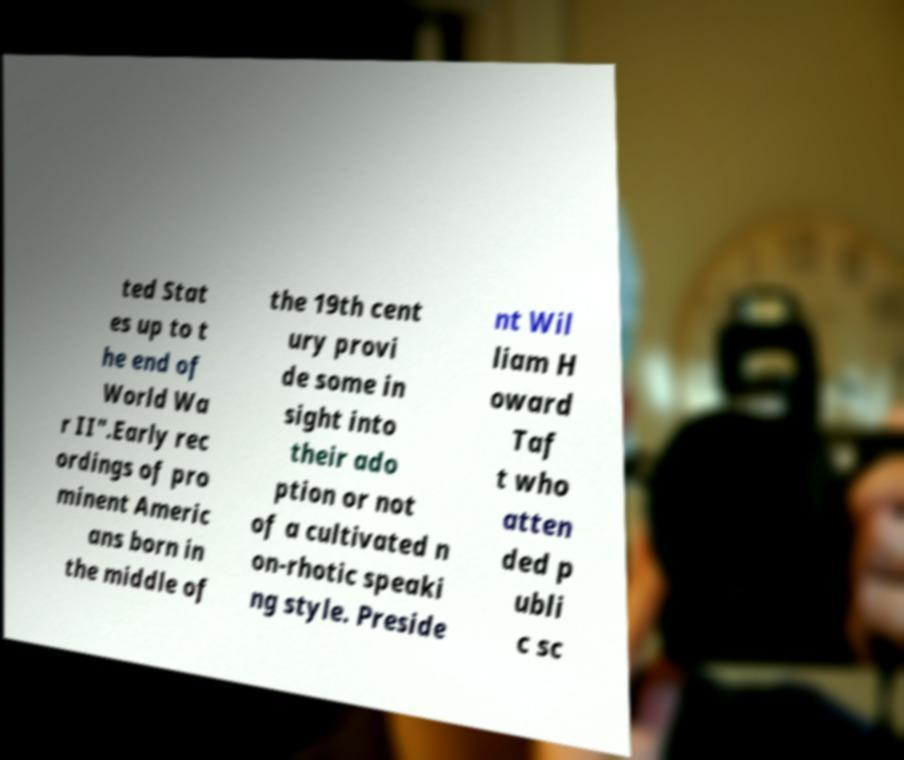Please identify and transcribe the text found in this image. ted Stat es up to t he end of World Wa r II".Early rec ordings of pro minent Americ ans born in the middle of the 19th cent ury provi de some in sight into their ado ption or not of a cultivated n on-rhotic speaki ng style. Preside nt Wil liam H oward Taf t who atten ded p ubli c sc 